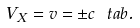<formula> <loc_0><loc_0><loc_500><loc_500>V _ { X } = v = \pm c \ t a b .</formula> 